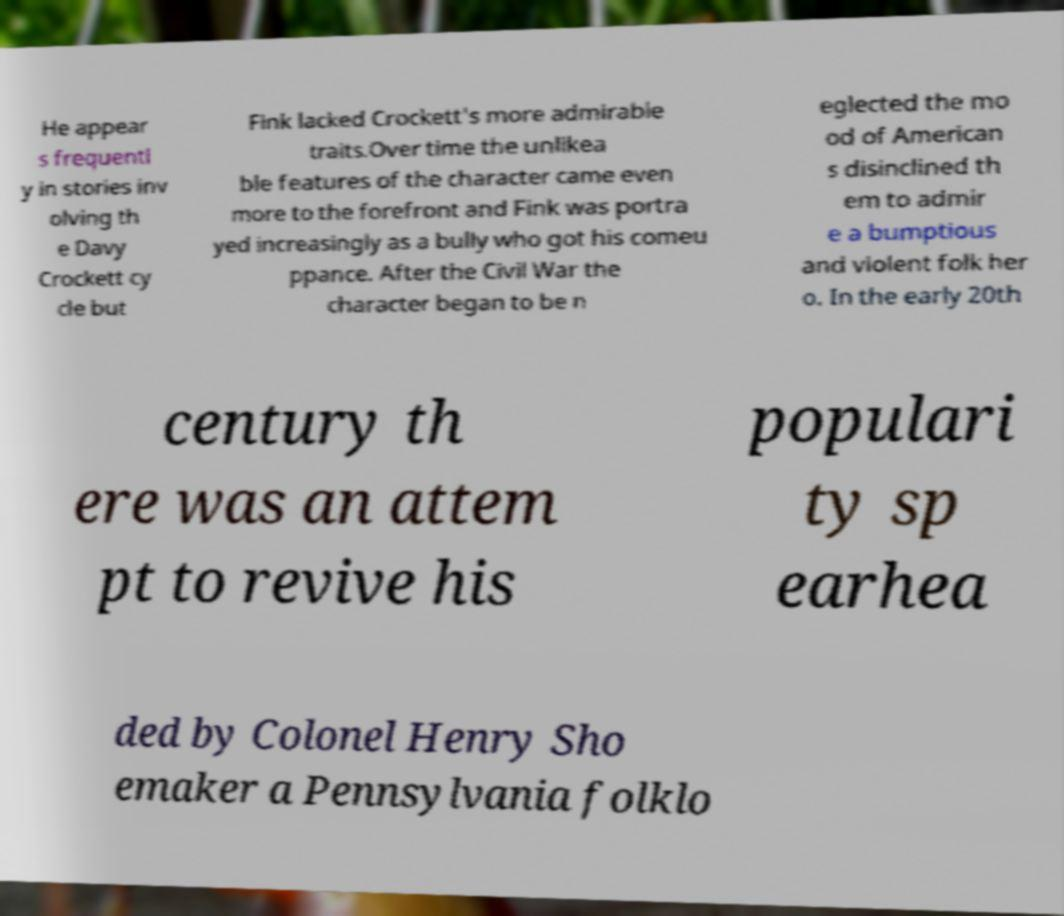Please identify and transcribe the text found in this image. He appear s frequentl y in stories inv olving th e Davy Crockett cy cle but Fink lacked Crockett's more admirable traits.Over time the unlikea ble features of the character came even more to the forefront and Fink was portra yed increasingly as a bully who got his comeu ppance. After the Civil War the character began to be n eglected the mo od of American s disinclined th em to admir e a bumptious and violent folk her o. In the early 20th century th ere was an attem pt to revive his populari ty sp earhea ded by Colonel Henry Sho emaker a Pennsylvania folklo 